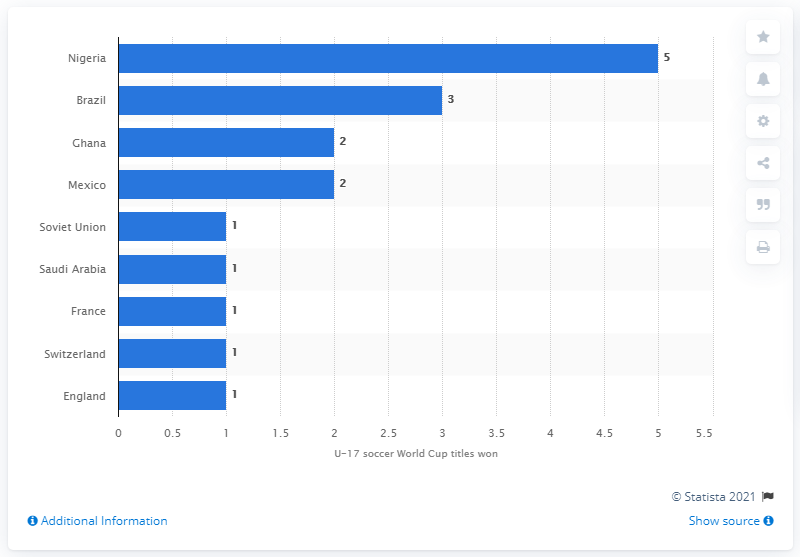Identify some key points in this picture. England is the reigning champion of the U-17 World Cup. 